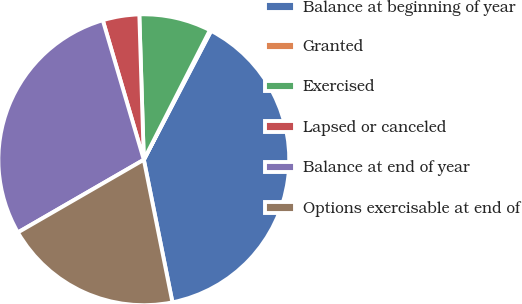<chart> <loc_0><loc_0><loc_500><loc_500><pie_chart><fcel>Balance at beginning of year<fcel>Granted<fcel>Exercised<fcel>Lapsed or canceled<fcel>Balance at end of year<fcel>Options exercisable at end of<nl><fcel>39.19%<fcel>0.15%<fcel>8.0%<fcel>4.06%<fcel>28.78%<fcel>19.82%<nl></chart> 